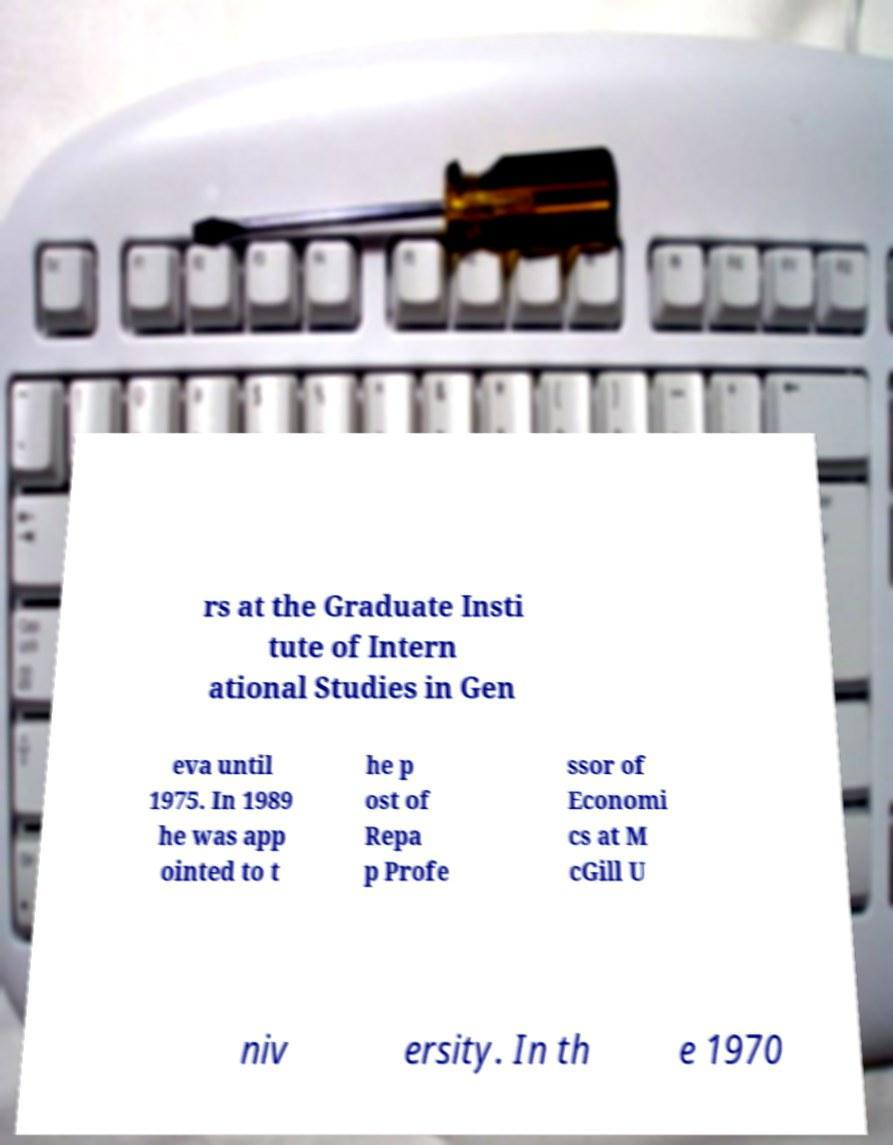Can you accurately transcribe the text from the provided image for me? rs at the Graduate Insti tute of Intern ational Studies in Gen eva until 1975. In 1989 he was app ointed to t he p ost of Repa p Profe ssor of Economi cs at M cGill U niv ersity. In th e 1970 